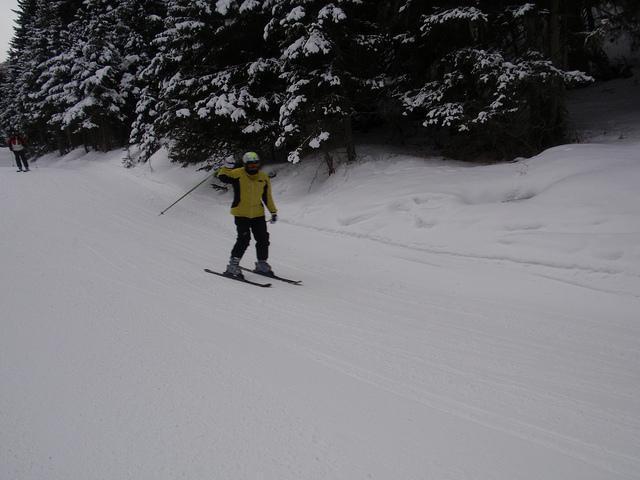How many people are in the picture?
Give a very brief answer. 2. 